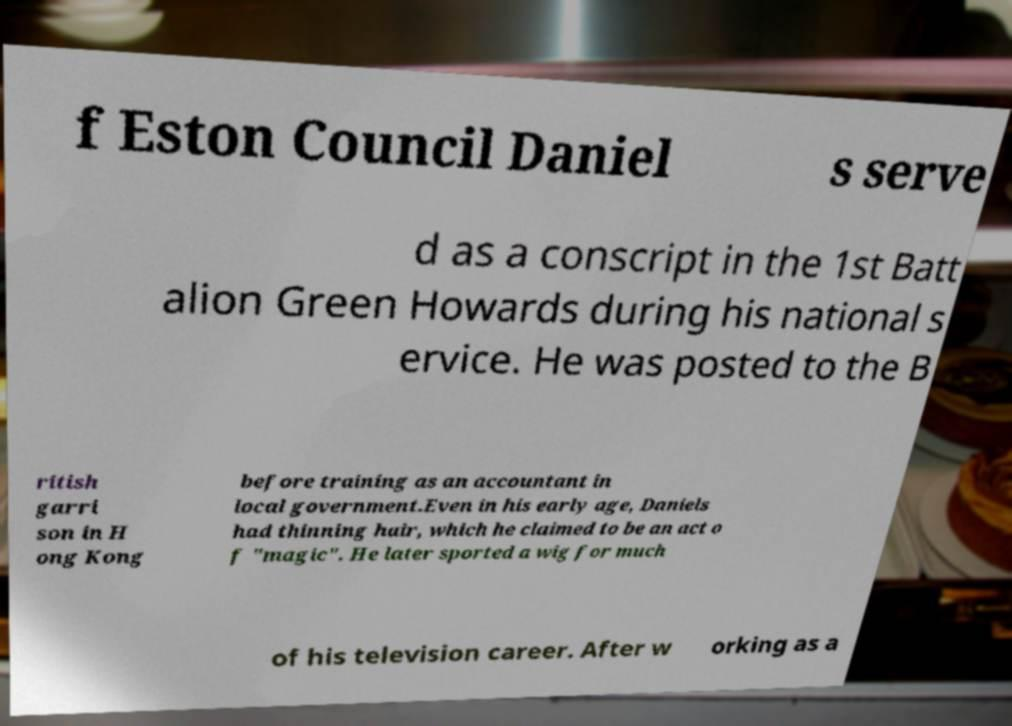Please identify and transcribe the text found in this image. f Eston Council Daniel s serve d as a conscript in the 1st Batt alion Green Howards during his national s ervice. He was posted to the B ritish garri son in H ong Kong before training as an accountant in local government.Even in his early age, Daniels had thinning hair, which he claimed to be an act o f "magic". He later sported a wig for much of his television career. After w orking as a 